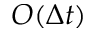<formula> <loc_0><loc_0><loc_500><loc_500>O ( \Delta t )</formula> 